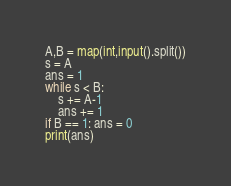Convert code to text. <code><loc_0><loc_0><loc_500><loc_500><_Python_>A,B = map(int,input().split())
s = A
ans = 1
while s < B:
    s += A-1
    ans += 1
if B == 1: ans = 0
print(ans)</code> 